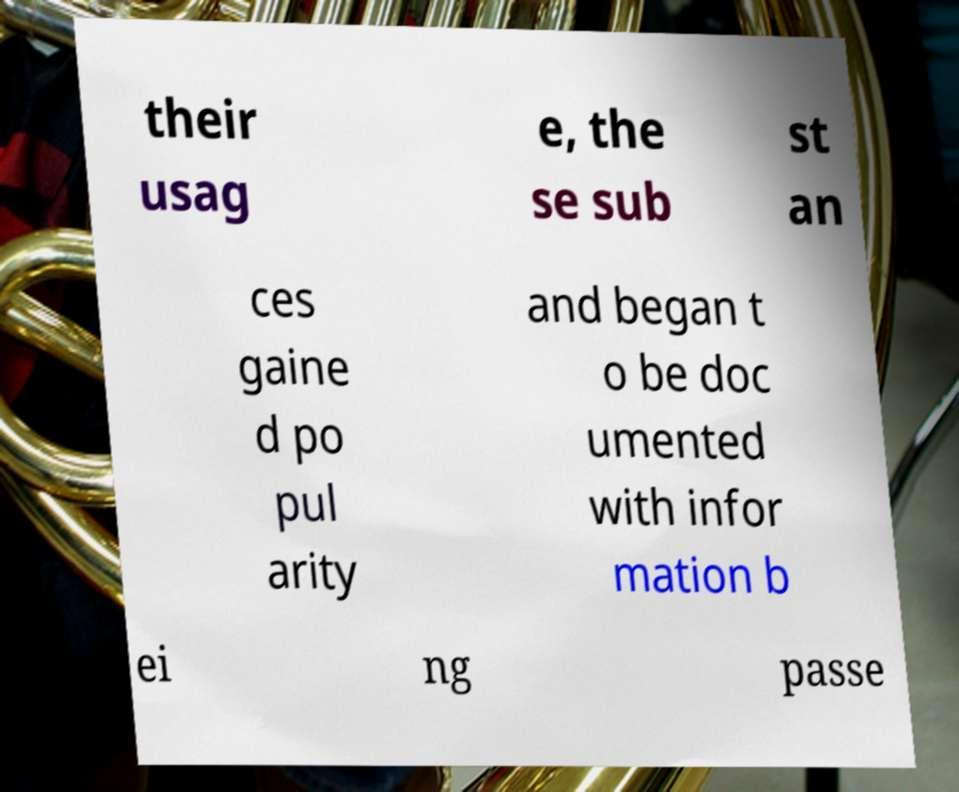What messages or text are displayed in this image? I need them in a readable, typed format. their usag e, the se sub st an ces gaine d po pul arity and began t o be doc umented with infor mation b ei ng passe 